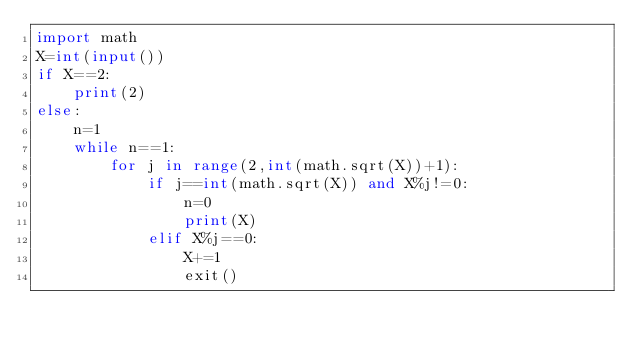<code> <loc_0><loc_0><loc_500><loc_500><_Python_>import math
X=int(input())
if X==2:
    print(2)
else:
    n=1
    while n==1:
        for j in range(2,int(math.sqrt(X))+1):
            if j==int(math.sqrt(X)) and X%j!=0:
                n=0
                print(X)
            elif X%j==0:
                X+=1
                exit()
  </code> 